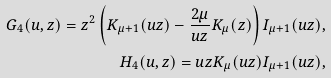<formula> <loc_0><loc_0><loc_500><loc_500>G _ { 4 } ( u , z ) = z ^ { 2 } \left ( K _ { \mu + 1 } ( u z ) - \frac { 2 \mu } { u z } K _ { \mu } ( z ) \right ) I _ { \mu + 1 } ( u z ) , \\ H _ { 4 } ( u , z ) = u z K _ { \mu } ( u z ) I _ { \mu + 1 } ( u z ) ,</formula> 